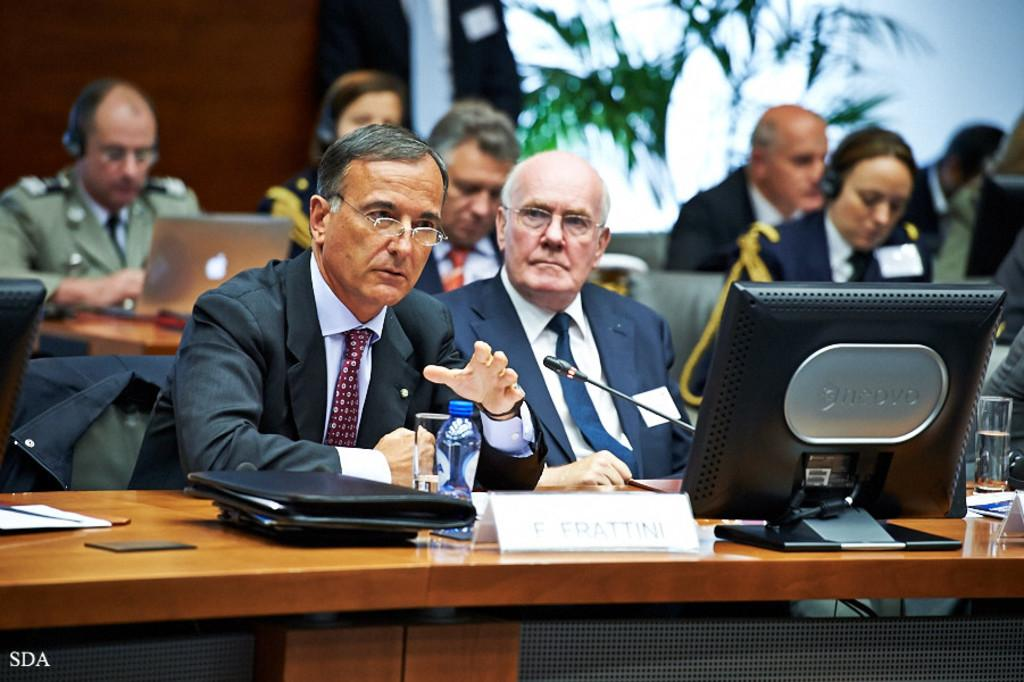What are the people in the image doing? The people in the image are sitting on chairs. What can be seen on the table in the image? There are water bottles, files, and a monitor on the table. What type of bone is visible on the table in the image? There is no bone present on the table in the image. 